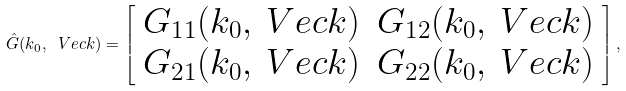Convert formula to latex. <formula><loc_0><loc_0><loc_500><loc_500>\hat { G } ( k _ { 0 } , \ V e c { k } ) = \left [ \begin{array} { c c } G _ { 1 1 } ( k _ { 0 } , \ V e c { k } ) & G _ { 1 2 } ( k _ { 0 } , \ V e c { k } ) \\ G _ { 2 1 } ( k _ { 0 } , \ V e c { k } ) & G _ { 2 2 } ( k _ { 0 } , \ V e c { k } ) \end{array} \right ] ,</formula> 